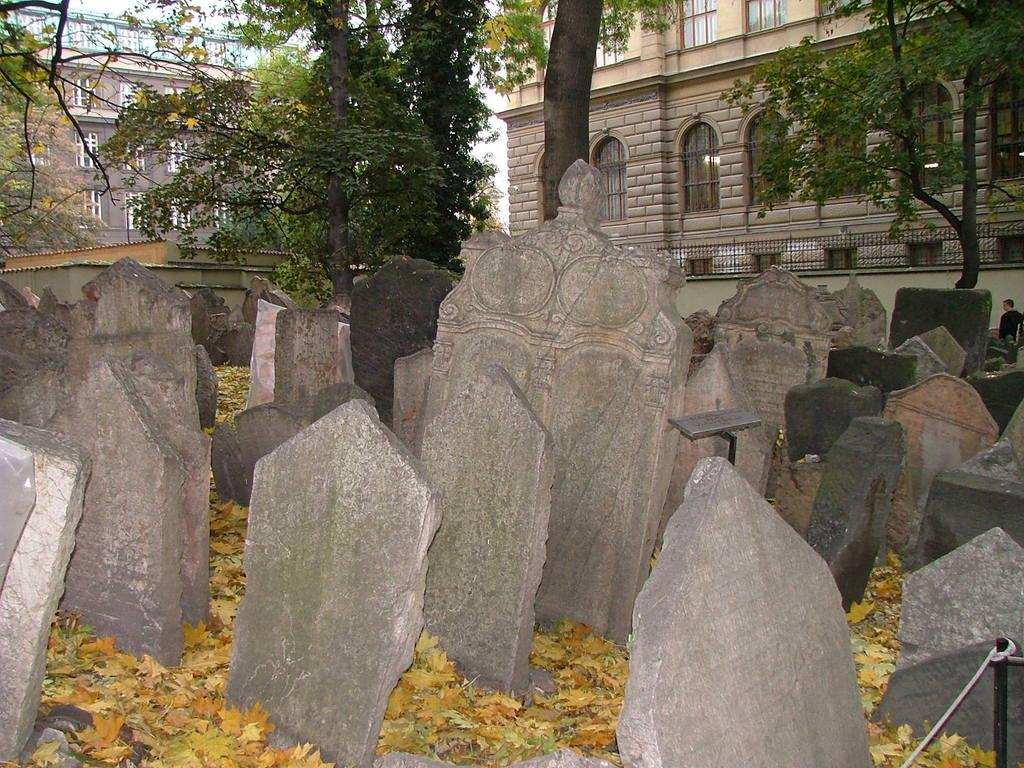What type of structures can be seen at the bottom of the image? There are cemeteries at the bottom of the image. What type of vegetation is present in the image? There are leaves and trees in the image. What type of buildings can be seen in the background of the image? There are houses in the background of the image. What type of natural features are visible in the background of the image? There are trees in the background of the image. How many people are visible in the image? There is one person visible in the image. What language is the person speaking in the image? There is no indication of the person speaking in the image, so it is not possible to determine the language they might be using. How many spades are visible in the image? There are no spades present in the image. 